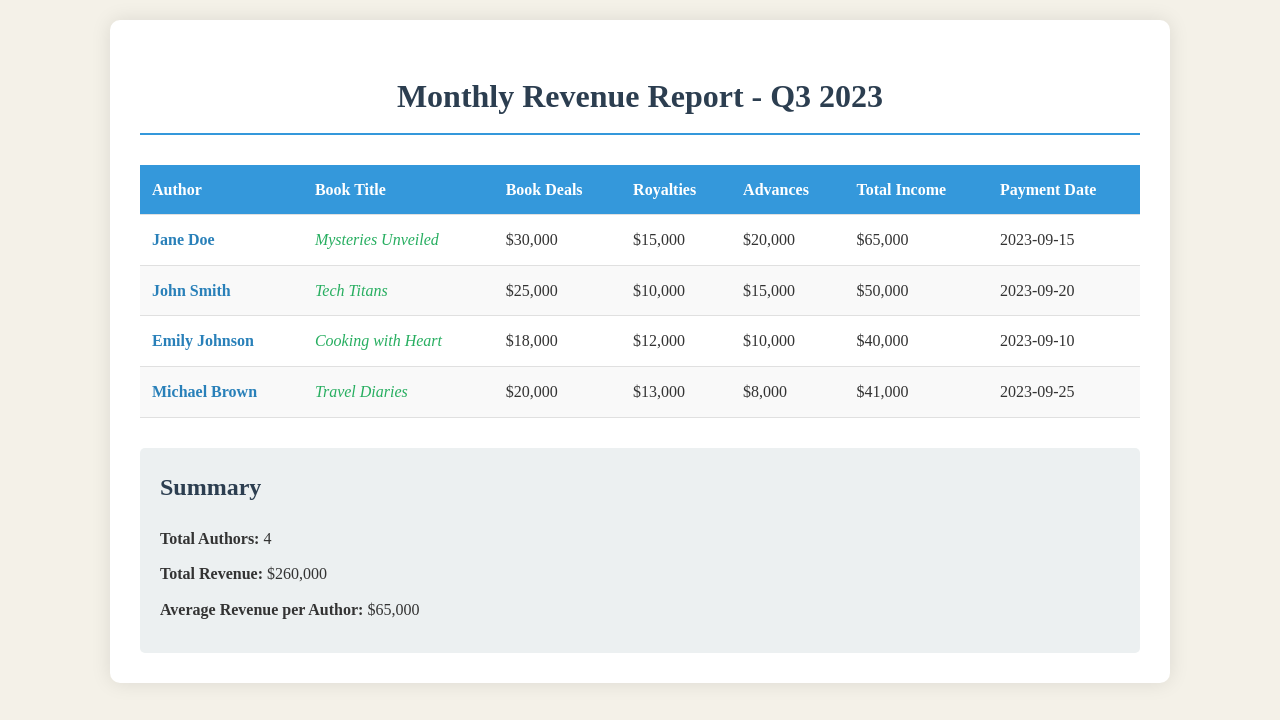What is the total revenue? The total revenue is the sum of all total incomes for the authors listed in the document, which is $65,000 + $50,000 + $40,000 + $41,000 = $260,000.
Answer: $260,000 Who is the author of "Tech Titans"? The document lists John Smith as the author associated with "Tech Titans".
Answer: John Smith What was the payment date for "Cooking with Heart"? The document specifies that the payment date for "Cooking with Heart" was September 10, 2023.
Answer: 2023-09-10 What is the total income of Jane Doe? The document indicates that Jane Doe earned a total income of $65,000 from her book deals, royalties, and advances.
Answer: $65,000 Which author received the highest advances? By analyzing the advances, Jane Doe received $20,000, which is the highest among the authors listed.
Answer: Jane Doe What is the average revenue per author? The average revenue per author is calculated by dividing the total revenue by the number of authors, which is $260,000 / 4 = $65,000.
Answer: $65,000 What book title does Michael Brown have? The document identifies "Travel Diaries" as the book title by Michael Brown.
Answer: Travel Diaries How many authors are represented in the report? The document states there are a total of 4 authors included in the revenue report.
Answer: 4 What is the total amount of royalties received by all authors combined? The total royalties are the sum of all royalties: $15,000 + $10,000 + $12,000 + $13,000 = $50,000.
Answer: $50,000 